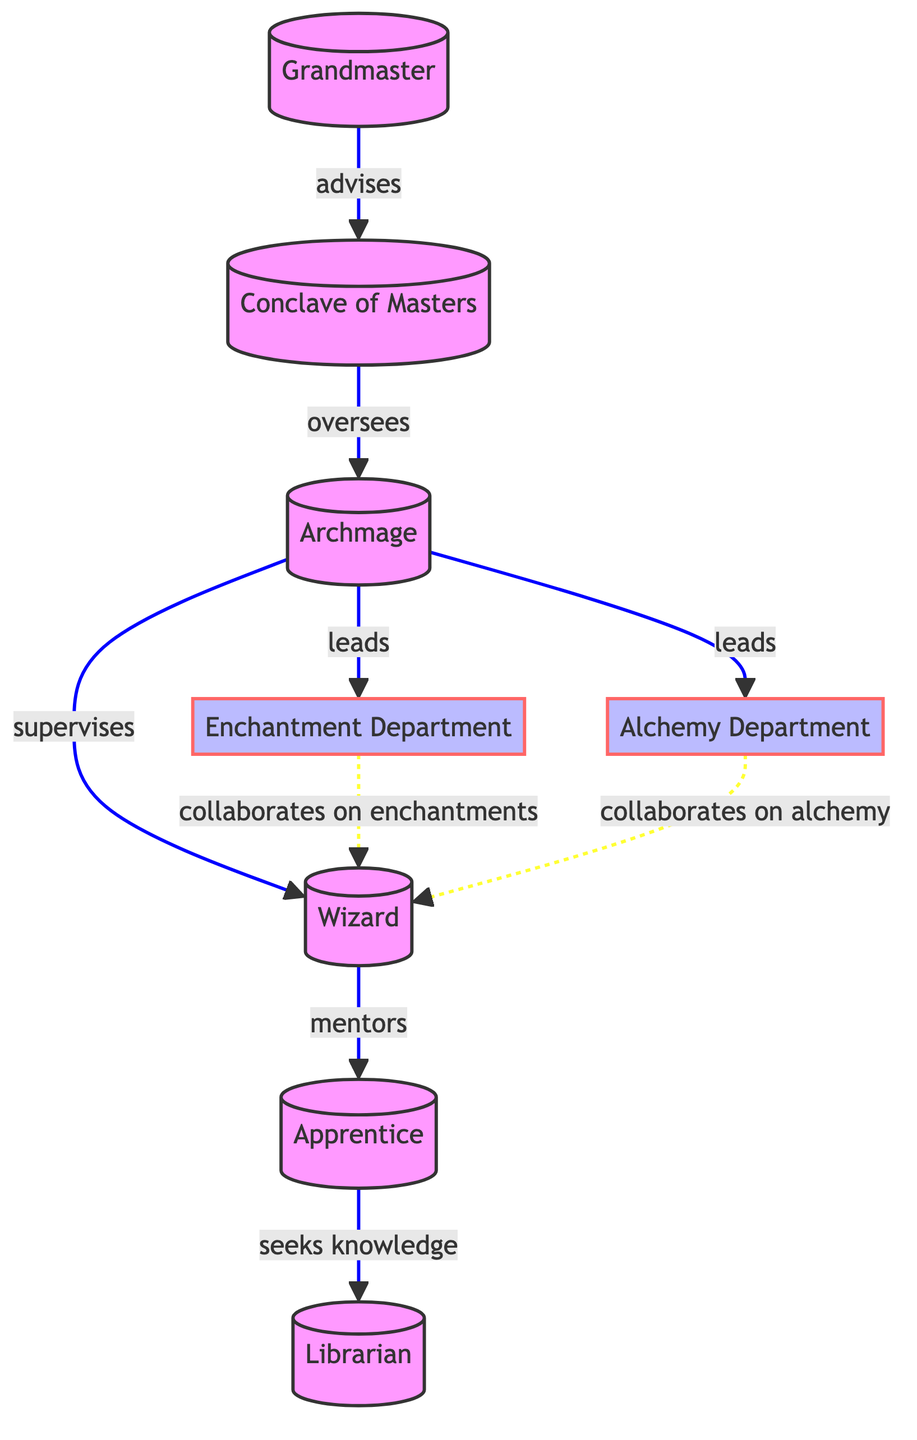What is the highest authority in the wizarding guild? The highest authority in the wizarding guild is the Grandmaster, as indicated by the node at level one in the diagram.
Answer: Grandmaster How many nodes are present in the diagram? The diagram has eight nodes representing different roles or departments in the wizarding guild, as counted from the node list provided.
Answer: 8 Which node seeks knowledge from the Librarian? The arrow originating from the Apprentice node points towards the Librarian node, indicating that Apprentices seek knowledge from Librarians.
Answer: Apprentice What relationship exists between the Conclave of Masters and the Archmage? The edge connecting the Conclave of Masters to the Archmage shows that the Conclave of Masters oversees the Archmage, denoting a supervisory relationship.
Answer: oversees Which department is led by an Archmage? Both the Enchantment Department and Alchemy Department have edges that originate from the Archmage node with the relationship labeled as "leads," indicating that the Archmage leads both departments.
Answer: Enchantment Department and Alchemy Department How does the Wizard mentor the Apprentice? The edge pointing from the Wizard to the Apprentice establishes a mentorship relationship, where Wizards provide guidance and teaching to Apprentices directly.
Answer: mentors Who collaborates with Wizards on enchantments? The Enchantment Department connects with the Wizard node with the relationship labeled as "collaborates on enchantments," implying that Wizards work directly with this department on spell-related tasks.
Answer: Enchantment Department Which role is positioned just below the Archmage in the hierarchy? The Wizard node is directly connected to the Archmage node through a supervising relationship, indicating that Wizards are the immediate subordinates of Archmages within the guild structure.
Answer: Wizard What is the relationship between the Archmage and the Librarian? There is no direct edge between the Archmage and the Librarian node; Apprentices seek knowledge from the Librarian, but they do not have a direct relationship with the Archmage.
Answer: None 